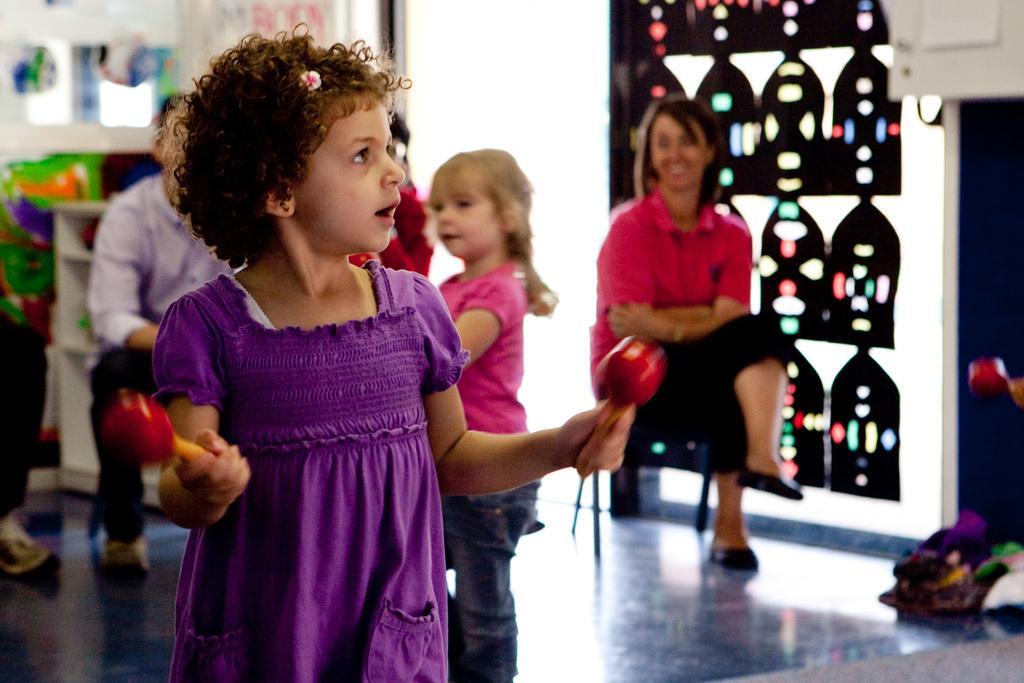Can you describe this image briefly? In this image we can see a girl is standing and holding objects in her hands. In the background we can see few persons are sitting on the chairs on the floor and kids are standing on the floor and we can see objects. 